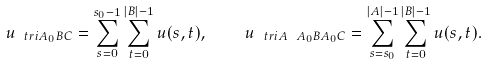Convert formula to latex. <formula><loc_0><loc_0><loc_500><loc_500>u _ { \ t r i { A _ { 0 } } { B } { C } } = \sum _ { s = 0 } ^ { s _ { 0 } - 1 } \sum _ { t = 0 } ^ { | B | - 1 } u ( s , t ) , \quad u _ { \ t r i { A \ A _ { 0 } } { B } { A _ { 0 } C } } = \sum _ { s = s _ { 0 } } ^ { | A | - 1 } \sum _ { t = 0 } ^ { | B | - 1 } u ( s , t ) .</formula> 